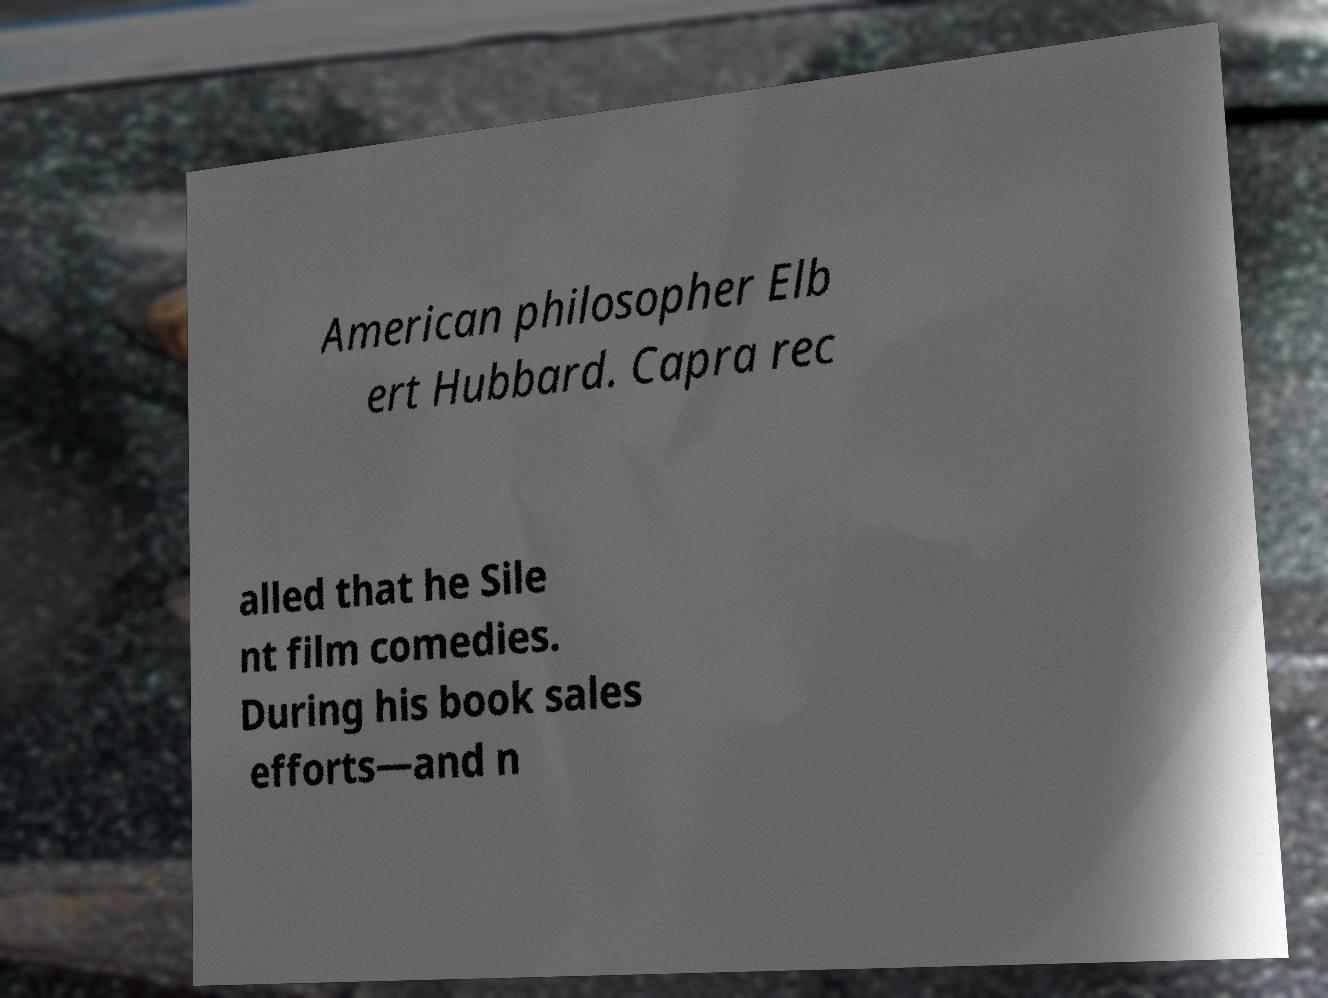Can you accurately transcribe the text from the provided image for me? American philosopher Elb ert Hubbard. Capra rec alled that he Sile nt film comedies. During his book sales efforts—and n 